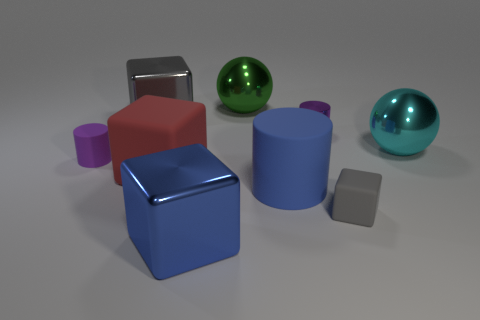Subtract all red rubber cubes. How many cubes are left? 3 Subtract all brown cylinders. How many gray cubes are left? 2 Subtract all red blocks. How many blocks are left? 3 Subtract all spheres. How many objects are left? 7 Subtract all purple blocks. Subtract all green cylinders. How many blocks are left? 4 Add 7 big cylinders. How many big cylinders exist? 8 Subtract 1 blue cylinders. How many objects are left? 8 Subtract all tiny rubber cylinders. Subtract all gray metal cubes. How many objects are left? 7 Add 8 tiny cubes. How many tiny cubes are left? 9 